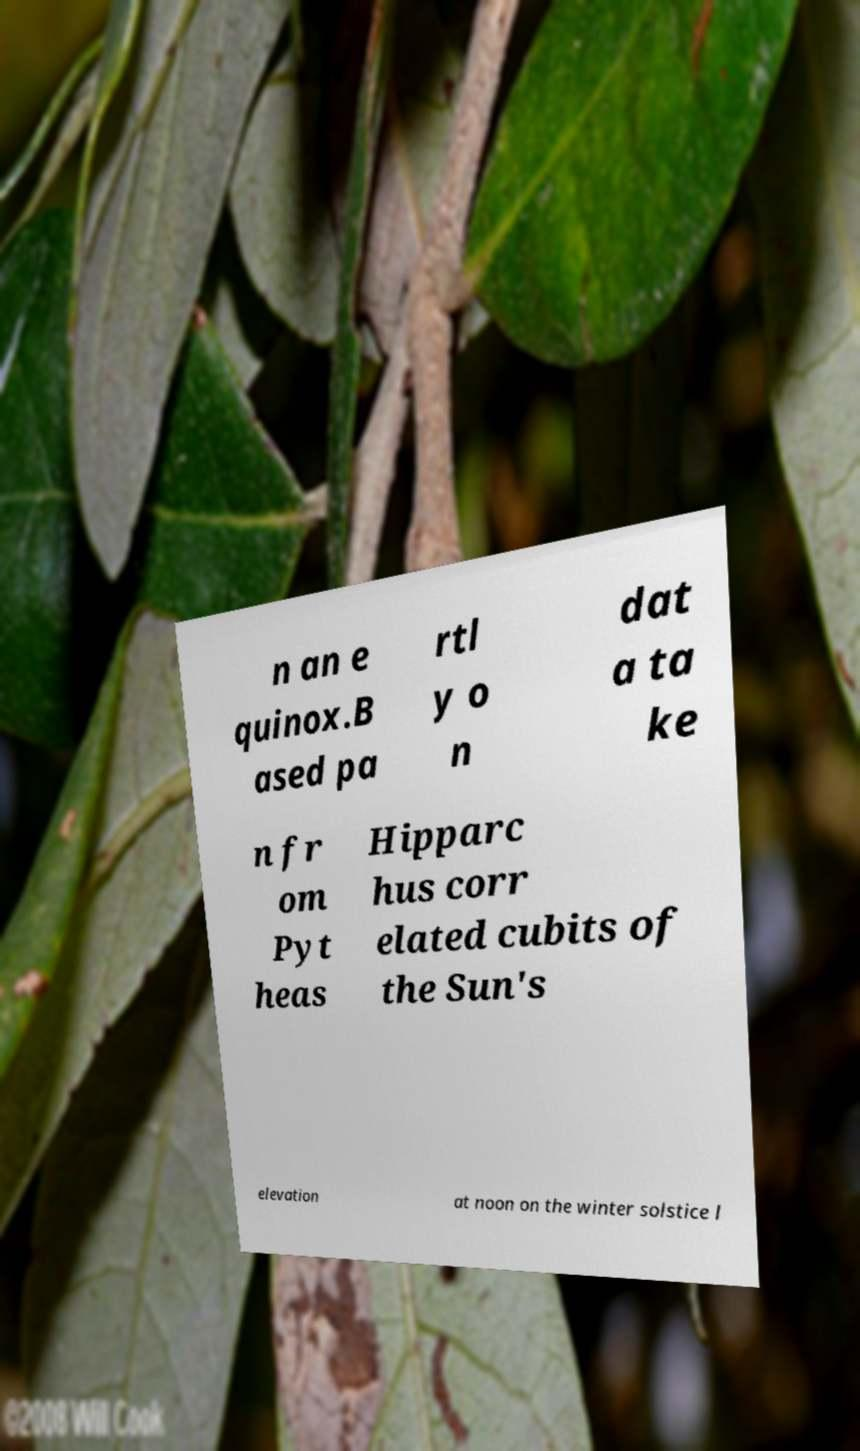Could you extract and type out the text from this image? n an e quinox.B ased pa rtl y o n dat a ta ke n fr om Pyt heas Hipparc hus corr elated cubits of the Sun's elevation at noon on the winter solstice l 